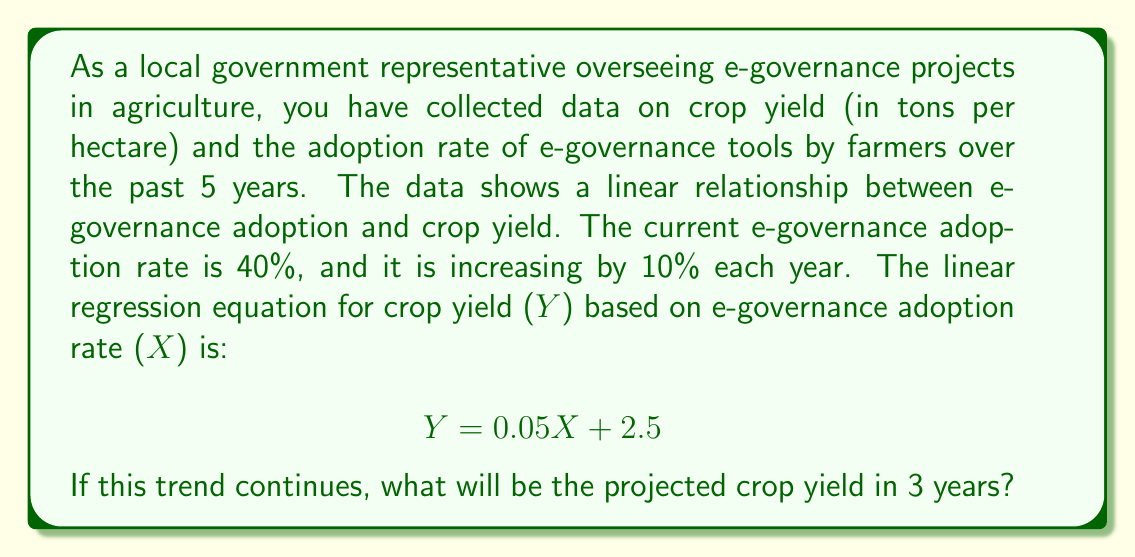Could you help me with this problem? To solve this problem, we need to follow these steps:

1. Calculate the e-governance adoption rate in 3 years:
   Current rate = 40%
   Annual increase = 10%
   Adoption rate in 3 years = $40\% + (3 \times 10\%) = 70\%$

2. Use the linear regression equation to calculate the projected crop yield:
   $$ Y = 0.05X + 2.5 $$
   Where:
   $Y$ = Crop yield (tons per hectare)
   $X$ = E-governance adoption rate (%)

3. Substitute the adoption rate in 3 years (70%) into the equation:
   $$ Y = 0.05(70) + 2.5 $$

4. Solve the equation:
   $$ Y = 3.5 + 2.5 = 6 $$

Therefore, the projected crop yield in 3 years will be 6 tons per hectare.
Answer: 6 tons per hectare 